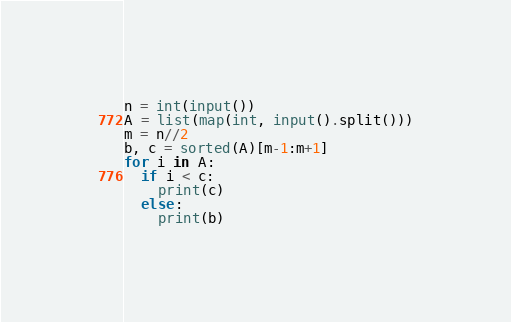<code> <loc_0><loc_0><loc_500><loc_500><_Python_>n = int(input())
A = list(map(int, input().split()))
m = n//2
b, c = sorted(A)[m-1:m+1]
for i in A:
  if i < c:
    print(c)
  else:
    print(b)</code> 